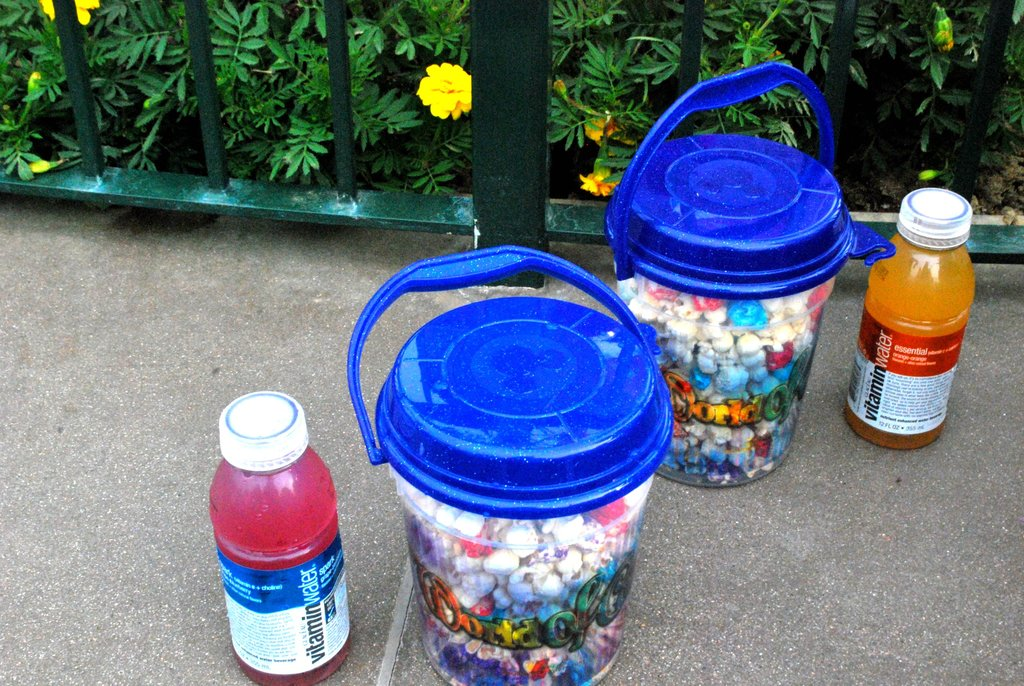What could be a creative use for these collected bottle caps? Collected bottle caps can be creatively used to make colorful mosaics, murals, or even functional items like tabletops and coasters. They offer a versatile material for various DIY art and decor projects. 